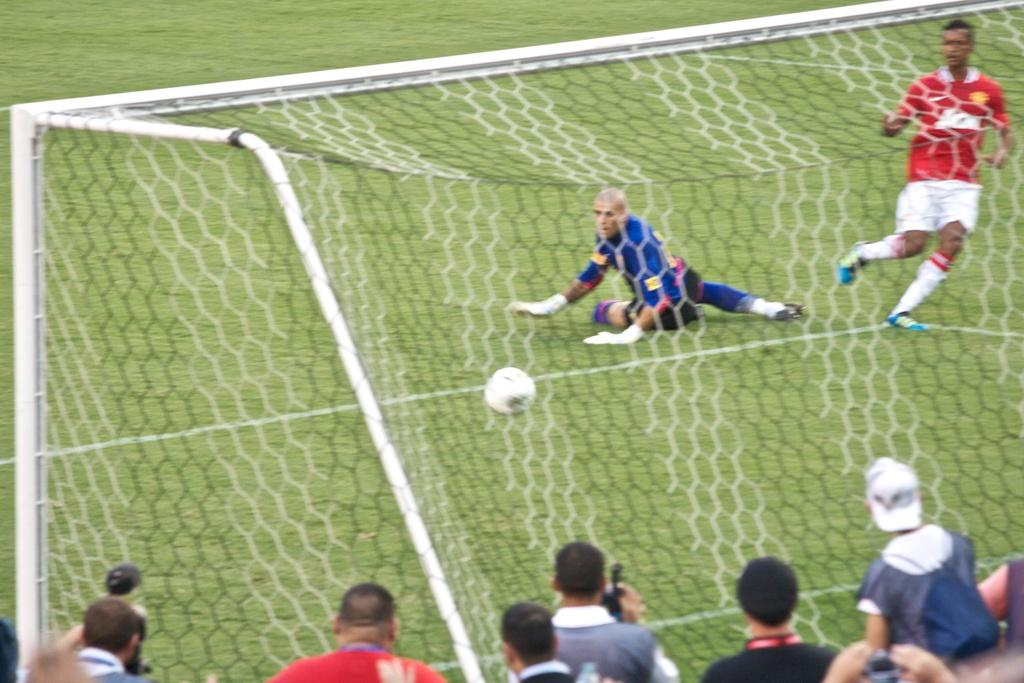What are the two persons in the image doing? The two persons in the image are playing football. Are there any other people present in the image besides the football players? Yes, people are taking pictures in front of the football players. What type of plough is being used to reduce friction between the football players and the ground in the image? There is no plough present in the image, and the football players are not using any equipment to reduce friction with the ground. 